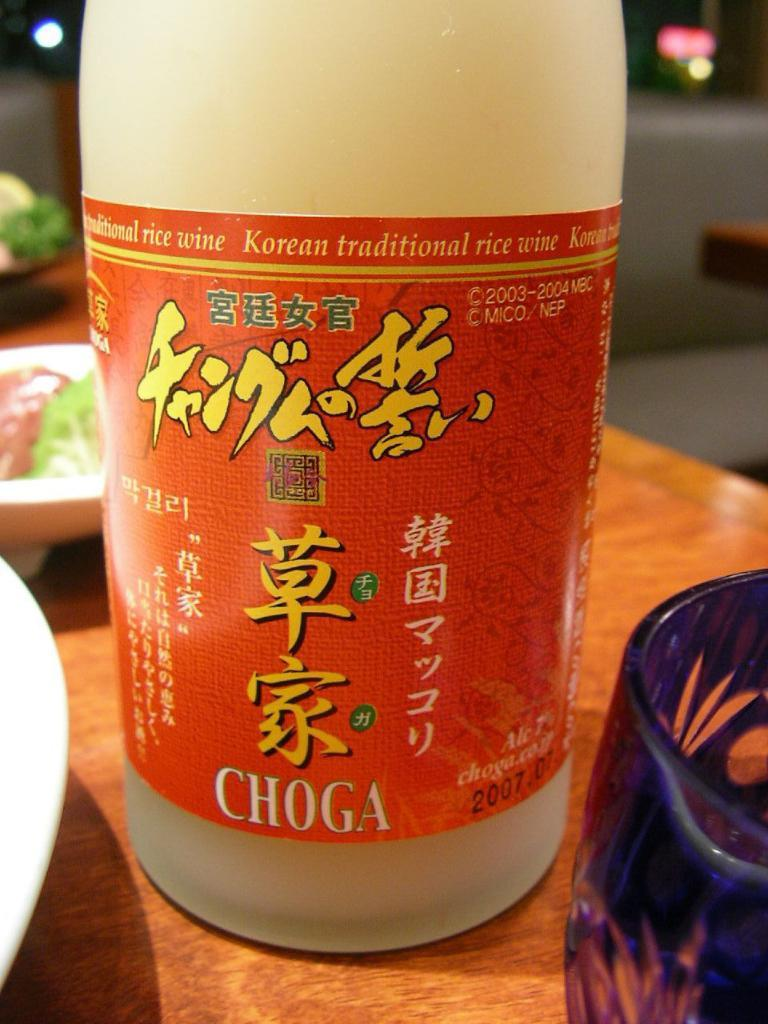<image>
Summarize the visual content of the image. A bottle of a drink called Choga with kanji characters 